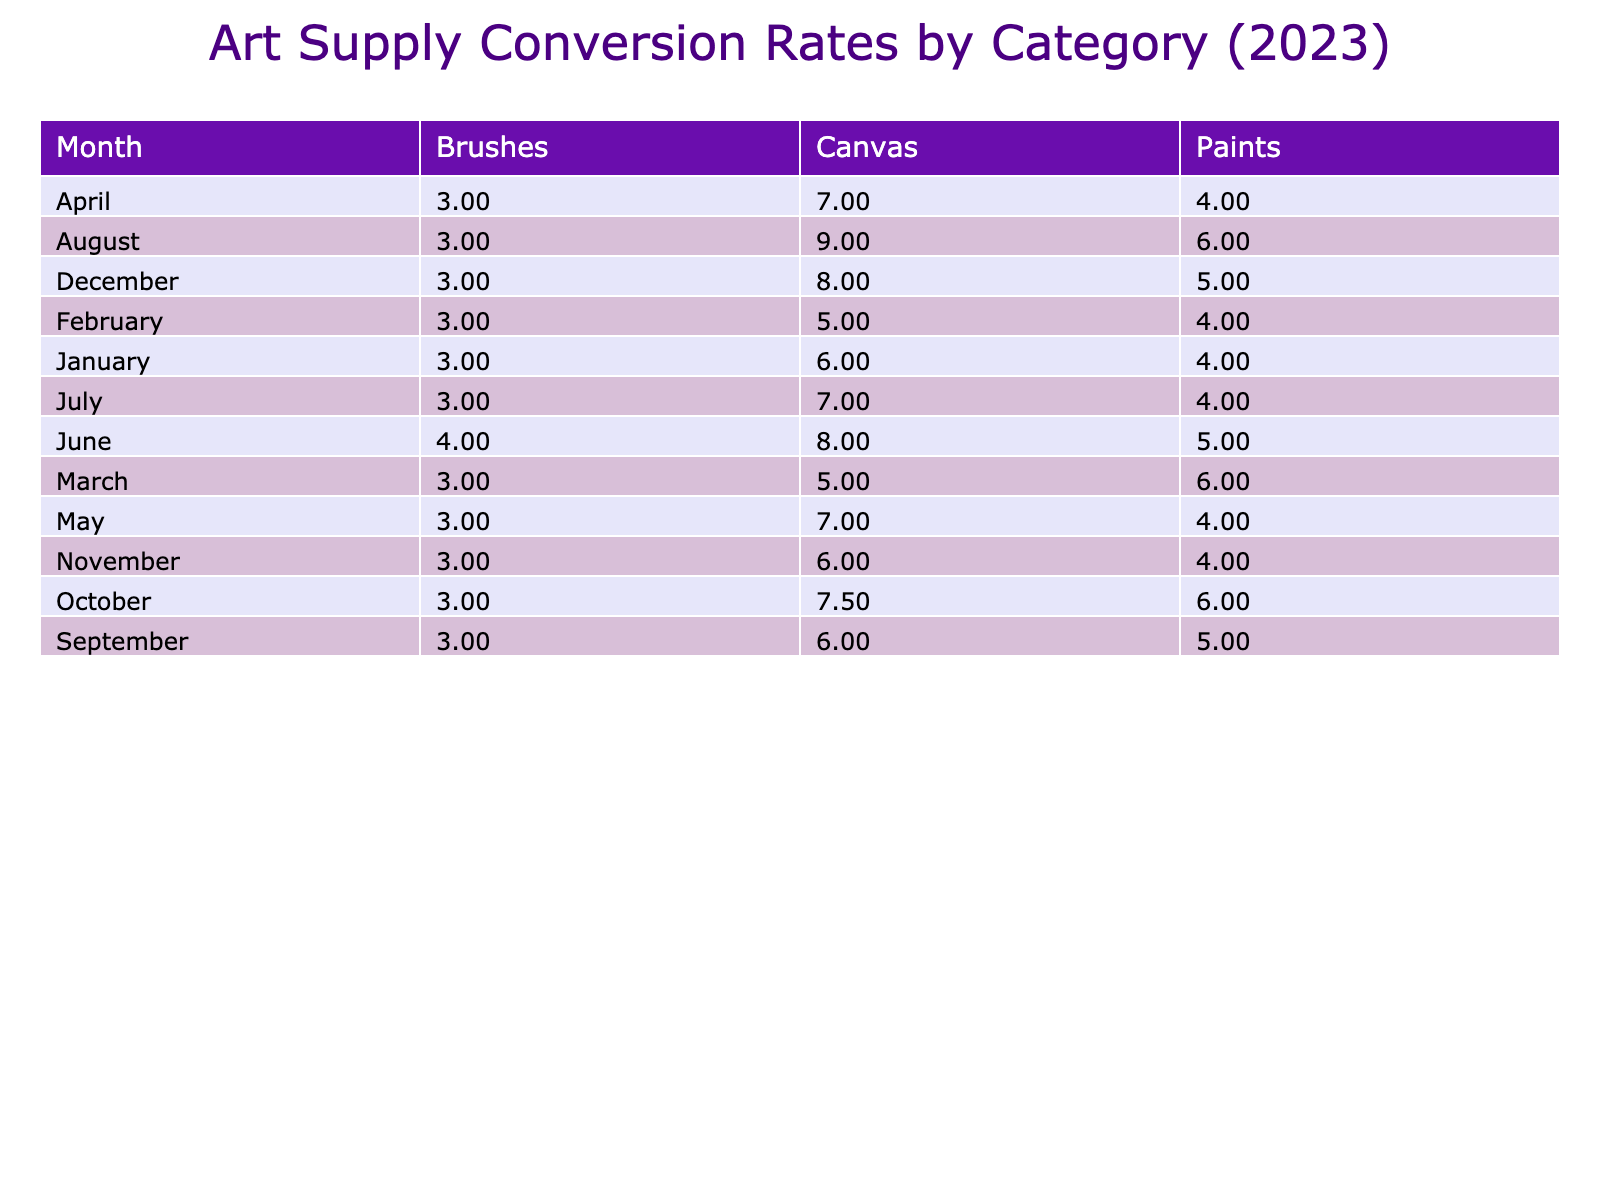What is the conversion rate for Acrylic Paints in January? The conversion rate for a specific item is calculated by dividing the revenue by the units sold. For Acrylic Paints in January, the revenue is 4800 and the units sold are 1200. So, the conversion rate is 4800 / 1200 = 4.00.
Answer: 4.00 Which month had the highest conversion rate for Canvas sales? To find the highest conversion rate for Canvas sales, we need to check each month's conversion rates for Canvas. The highest conversion rate is in April with Canvas Rolls, where the conversion rate is approximately 7.00 (4550 / 650).
Answer: April Did the conversion rate for Paints increase from January to December? We need to compare the conversion rates for Paints over the given months. In January, the conversion rate is 4.00, while in December, it is 5.00 (7500 / 1500). Since 5.00 is greater than 4.00, the conversion rate increased.
Answer: Yes What is the total revenue generated from Brushes in August? To find this, we look at the revenue for Brushes in August, which is 1950 (from Water Brushes) plus 2700 (from Brush Sets), giving a total of 4650 for that month.
Answer: 4650 Which category had the lowest overall conversion rate for the year? We need to calculate the conversion rate for each category by summing the total revenue and units sold for each. By calculating, we find that Brushes had the lowest overall conversion rate around 2.70, compared to other categories.
Answer: Brushes 